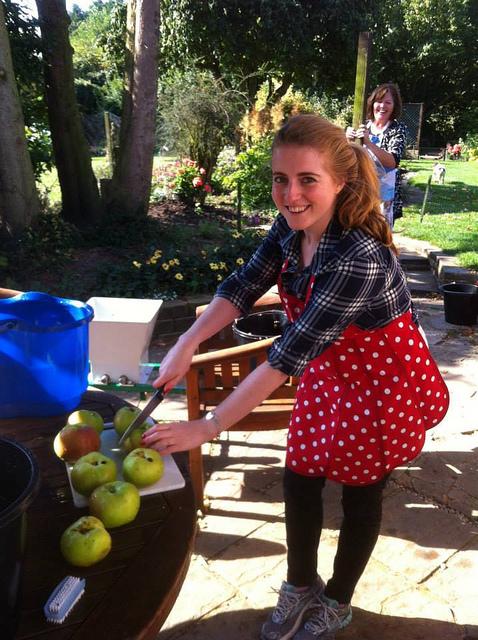What pattern is the girl's apron?
Answer briefly. Polka dot. What is the girl cutting?
Concise answer only. Apple. What is the girl smiling at?
Short answer required. Photographer. 